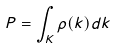<formula> <loc_0><loc_0><loc_500><loc_500>P = \int _ { K } \rho ( k ) d k</formula> 